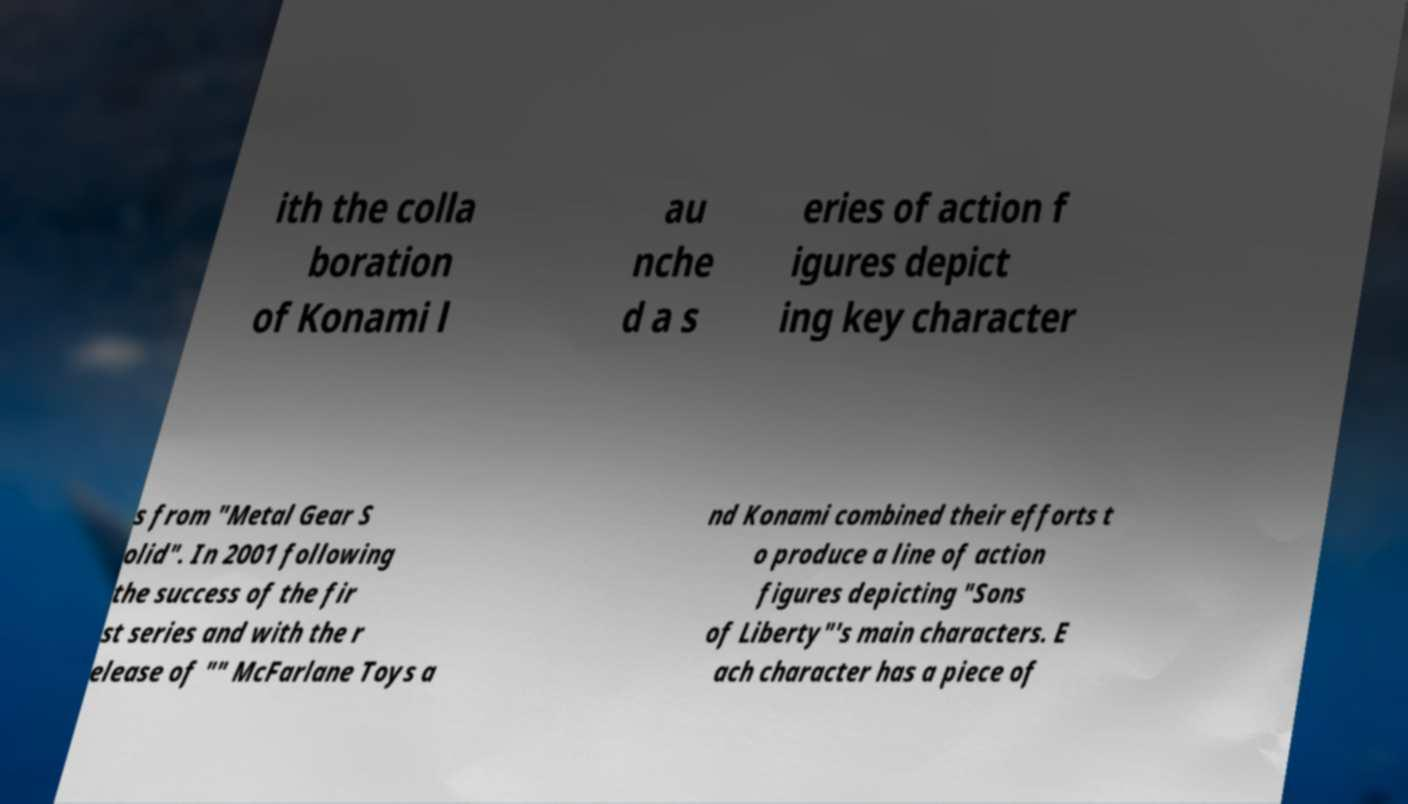What messages or text are displayed in this image? I need them in a readable, typed format. ith the colla boration of Konami l au nche d a s eries of action f igures depict ing key character s from "Metal Gear S olid". In 2001 following the success of the fir st series and with the r elease of "" McFarlane Toys a nd Konami combined their efforts t o produce a line of action figures depicting "Sons of Liberty"'s main characters. E ach character has a piece of 